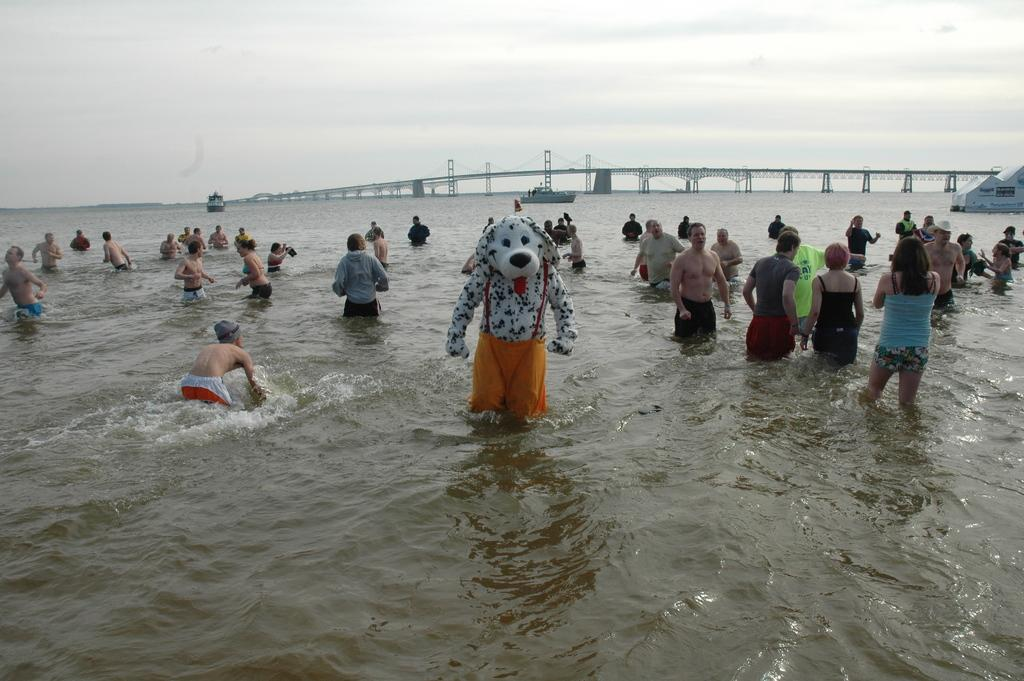What is the primary element in the image? There is water in the image. Are there any people present in the image? Yes, there are people in the image. What can be seen in the distance in the image? There is a bridge visible in the distance. How would you describe the sky in the image? The sky is cloudy in the image. What else is present above the water in the image? There are boats above the water in the image. How many books can be seen on the owl's back in the image? There are no books or owls present in the image. 